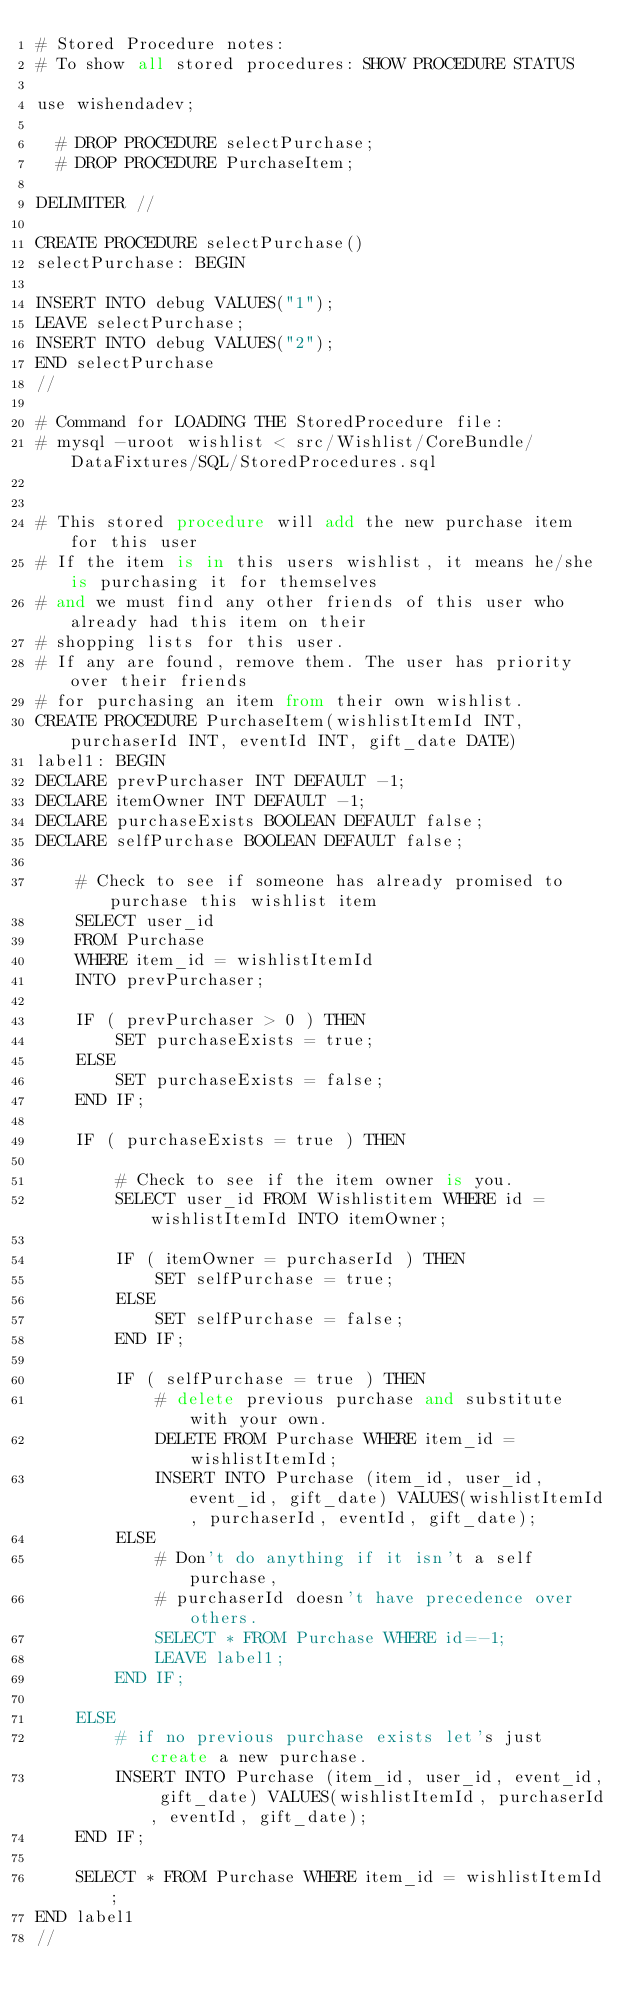Convert code to text. <code><loc_0><loc_0><loc_500><loc_500><_SQL_># Stored Procedure notes:
# To show all stored procedures: SHOW PROCEDURE STATUS

use wishendadev;

  # DROP PROCEDURE selectPurchase;
  # DROP PROCEDURE PurchaseItem;

DELIMITER //

CREATE PROCEDURE selectPurchase()
selectPurchase: BEGIN

INSERT INTO debug VALUES("1");
LEAVE selectPurchase;
INSERT INTO debug VALUES("2");
END selectPurchase
//

# Command for LOADING THE StoredProcedure file: 
# mysql -uroot wishlist < src/Wishlist/CoreBundle/DataFixtures/SQL/StoredProcedures.sql


# This stored procedure will add the new purchase item for this user
# If the item is in this users wishlist, it means he/she is purchasing it for themselves 
# and we must find any other friends of this user who already had this item on their 
# shopping lists for this user. 
# If any are found, remove them. The user has priority over their friends 
# for purchasing an item from their own wishlist. 
CREATE PROCEDURE PurchaseItem(wishlistItemId INT, purchaserId INT, eventId INT, gift_date DATE)
label1: BEGIN
DECLARE prevPurchaser INT DEFAULT -1;
DECLARE itemOwner INT DEFAULT -1;
DECLARE purchaseExists BOOLEAN DEFAULT false;
DECLARE selfPurchase BOOLEAN DEFAULT false;

    # Check to see if someone has already promised to purchase this wishlist item
    SELECT user_id 
    FROM Purchase 
    WHERE item_id = wishlistItemId
    INTO prevPurchaser;

    IF ( prevPurchaser > 0 ) THEN
        SET purchaseExists = true;
    ELSE
        SET purchaseExists = false;
    END IF;

    IF ( purchaseExists = true ) THEN

        # Check to see if the item owner is you.
        SELECT user_id FROM Wishlistitem WHERE id = wishlistItemId INTO itemOwner;
        
        IF ( itemOwner = purchaserId ) THEN
            SET selfPurchase = true;
        ELSE
            SET selfPurchase = false;
        END IF;

        IF ( selfPurchase = true ) THEN
            # delete previous purchase and substitute with your own.
            DELETE FROM Purchase WHERE item_id = wishlistItemId;
            INSERT INTO Purchase (item_id, user_id, event_id, gift_date) VALUES(wishlistItemId, purchaserId, eventId, gift_date);
        ELSE
            # Don't do anything if it isn't a self purchase, 
            # purchaserId doesn't have precedence over others.
            SELECT * FROM Purchase WHERE id=-1;
            LEAVE label1;        
        END IF; 

    ELSE
        # if no previous purchase exists let's just create a new purchase.
        INSERT INTO Purchase (item_id, user_id, event_id, gift_date) VALUES(wishlistItemId, purchaserId, eventId, gift_date);
    END IF;

    SELECT * FROM Purchase WHERE item_id = wishlistItemId;
END label1
//
</code> 